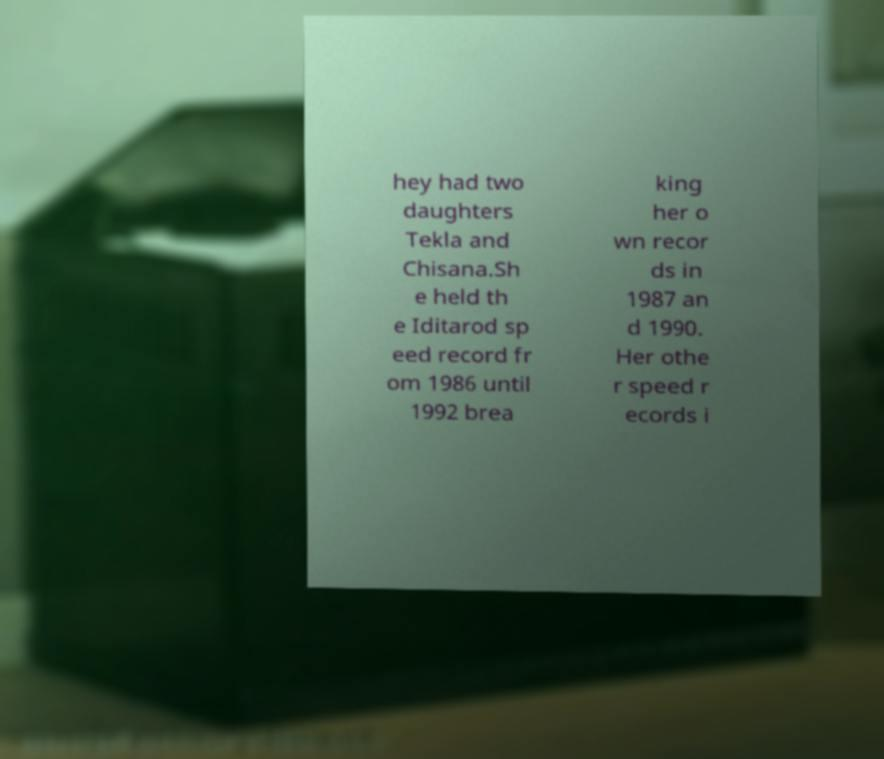For documentation purposes, I need the text within this image transcribed. Could you provide that? hey had two daughters Tekla and Chisana.Sh e held th e Iditarod sp eed record fr om 1986 until 1992 brea king her o wn recor ds in 1987 an d 1990. Her othe r speed r ecords i 